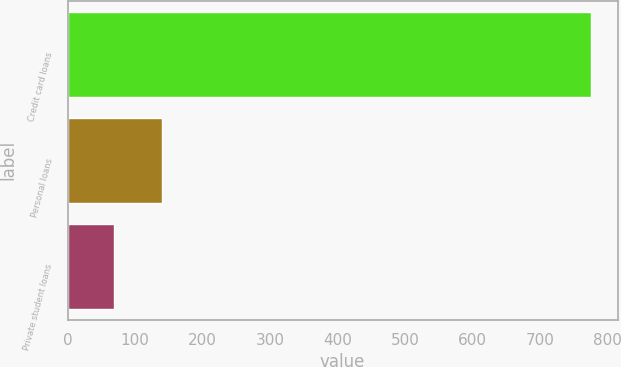Convert chart to OTSL. <chart><loc_0><loc_0><loc_500><loc_500><bar_chart><fcel>Credit card loans<fcel>Personal loans<fcel>Private student loans<nl><fcel>776<fcel>139.7<fcel>69<nl></chart> 